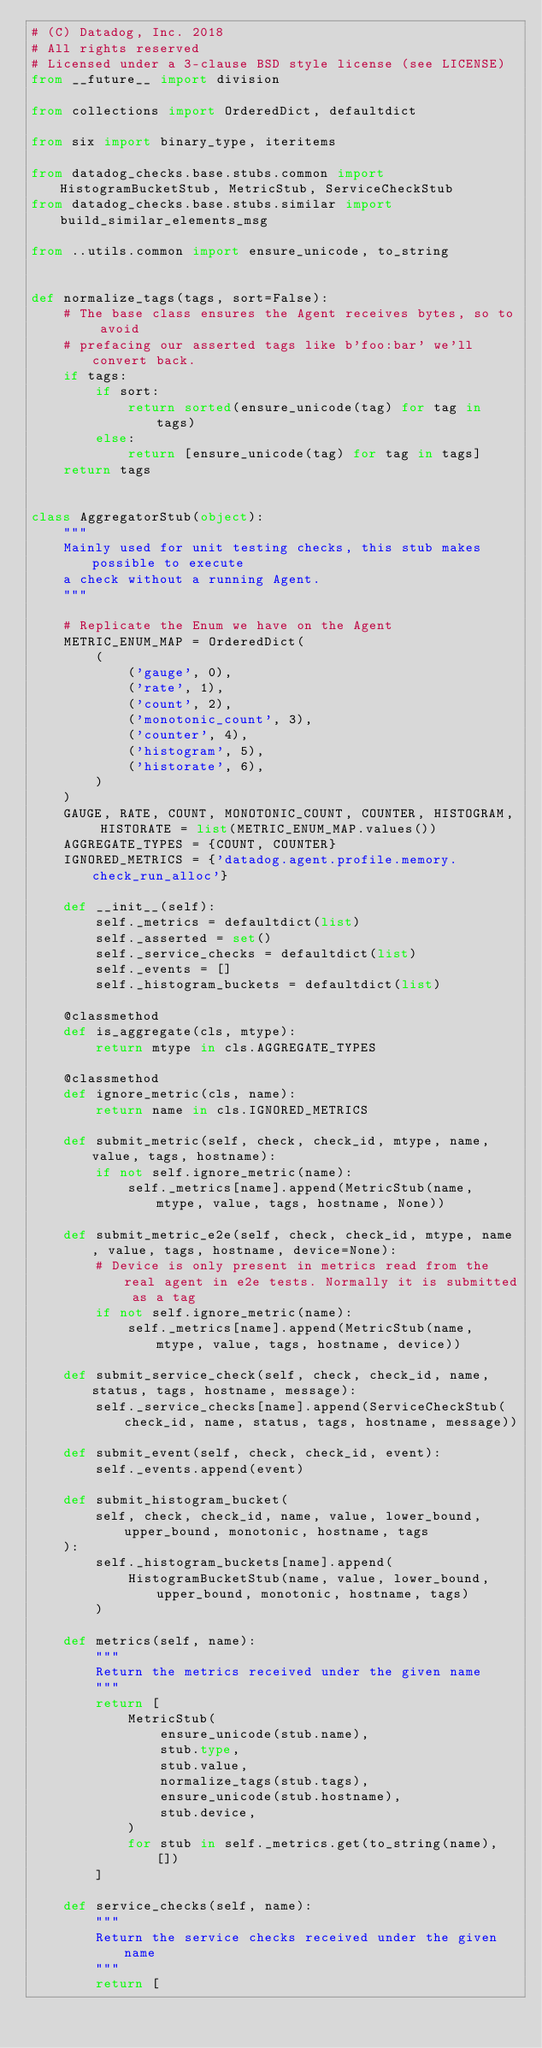<code> <loc_0><loc_0><loc_500><loc_500><_Python_># (C) Datadog, Inc. 2018
# All rights reserved
# Licensed under a 3-clause BSD style license (see LICENSE)
from __future__ import division

from collections import OrderedDict, defaultdict

from six import binary_type, iteritems

from datadog_checks.base.stubs.common import HistogramBucketStub, MetricStub, ServiceCheckStub
from datadog_checks.base.stubs.similar import build_similar_elements_msg

from ..utils.common import ensure_unicode, to_string


def normalize_tags(tags, sort=False):
    # The base class ensures the Agent receives bytes, so to avoid
    # prefacing our asserted tags like b'foo:bar' we'll convert back.
    if tags:
        if sort:
            return sorted(ensure_unicode(tag) for tag in tags)
        else:
            return [ensure_unicode(tag) for tag in tags]
    return tags


class AggregatorStub(object):
    """
    Mainly used for unit testing checks, this stub makes possible to execute
    a check without a running Agent.
    """

    # Replicate the Enum we have on the Agent
    METRIC_ENUM_MAP = OrderedDict(
        (
            ('gauge', 0),
            ('rate', 1),
            ('count', 2),
            ('monotonic_count', 3),
            ('counter', 4),
            ('histogram', 5),
            ('historate', 6),
        )
    )
    GAUGE, RATE, COUNT, MONOTONIC_COUNT, COUNTER, HISTOGRAM, HISTORATE = list(METRIC_ENUM_MAP.values())
    AGGREGATE_TYPES = {COUNT, COUNTER}
    IGNORED_METRICS = {'datadog.agent.profile.memory.check_run_alloc'}

    def __init__(self):
        self._metrics = defaultdict(list)
        self._asserted = set()
        self._service_checks = defaultdict(list)
        self._events = []
        self._histogram_buckets = defaultdict(list)

    @classmethod
    def is_aggregate(cls, mtype):
        return mtype in cls.AGGREGATE_TYPES

    @classmethod
    def ignore_metric(cls, name):
        return name in cls.IGNORED_METRICS

    def submit_metric(self, check, check_id, mtype, name, value, tags, hostname):
        if not self.ignore_metric(name):
            self._metrics[name].append(MetricStub(name, mtype, value, tags, hostname, None))

    def submit_metric_e2e(self, check, check_id, mtype, name, value, tags, hostname, device=None):
        # Device is only present in metrics read from the real agent in e2e tests. Normally it is submitted as a tag
        if not self.ignore_metric(name):
            self._metrics[name].append(MetricStub(name, mtype, value, tags, hostname, device))

    def submit_service_check(self, check, check_id, name, status, tags, hostname, message):
        self._service_checks[name].append(ServiceCheckStub(check_id, name, status, tags, hostname, message))

    def submit_event(self, check, check_id, event):
        self._events.append(event)

    def submit_histogram_bucket(
        self, check, check_id, name, value, lower_bound, upper_bound, monotonic, hostname, tags
    ):
        self._histogram_buckets[name].append(
            HistogramBucketStub(name, value, lower_bound, upper_bound, monotonic, hostname, tags)
        )

    def metrics(self, name):
        """
        Return the metrics received under the given name
        """
        return [
            MetricStub(
                ensure_unicode(stub.name),
                stub.type,
                stub.value,
                normalize_tags(stub.tags),
                ensure_unicode(stub.hostname),
                stub.device,
            )
            for stub in self._metrics.get(to_string(name), [])
        ]

    def service_checks(self, name):
        """
        Return the service checks received under the given name
        """
        return [</code> 